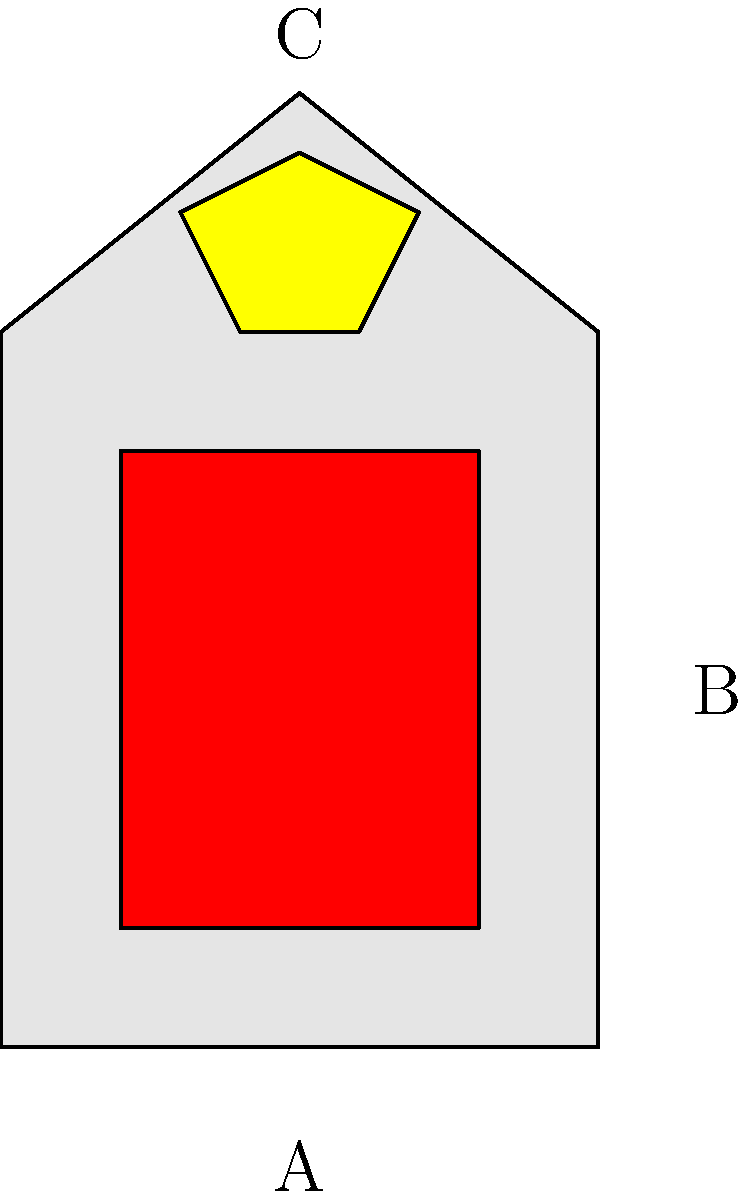In the Belgian family crest shown above, what does the red lion (B) typically symbolize in heraldry? To decode this family crest, we need to understand the common symbols in Belgian heraldry:

1. The shield shape (A) is typical of medieval European heraldry, including Belgian.

2. The red lion (B) is a central figure in the crest. In heraldry, lions are one of the most common animals and have specific meanings:
   a. Courage and strength
   b. Nobility and royalty
   c. Power and authority

3. The color red (gules in heraldic terms) typically symbolizes:
   a. Warrior or martyr
   b. Military strength and magnanimity

4. The crown (C) above the lion suggests a connection to royalty or nobility.

In Belgian heraldry, particularly in the Flemish region, the red lion on a gold or silver background is a prevalent symbol. It's associated with the historical County of Flanders and represents bravery and strength.

Considering all these elements, the red lion in this Belgian family crest most likely symbolizes courage and nobility, with a possible connection to Flemish heritage.
Answer: Courage and nobility 